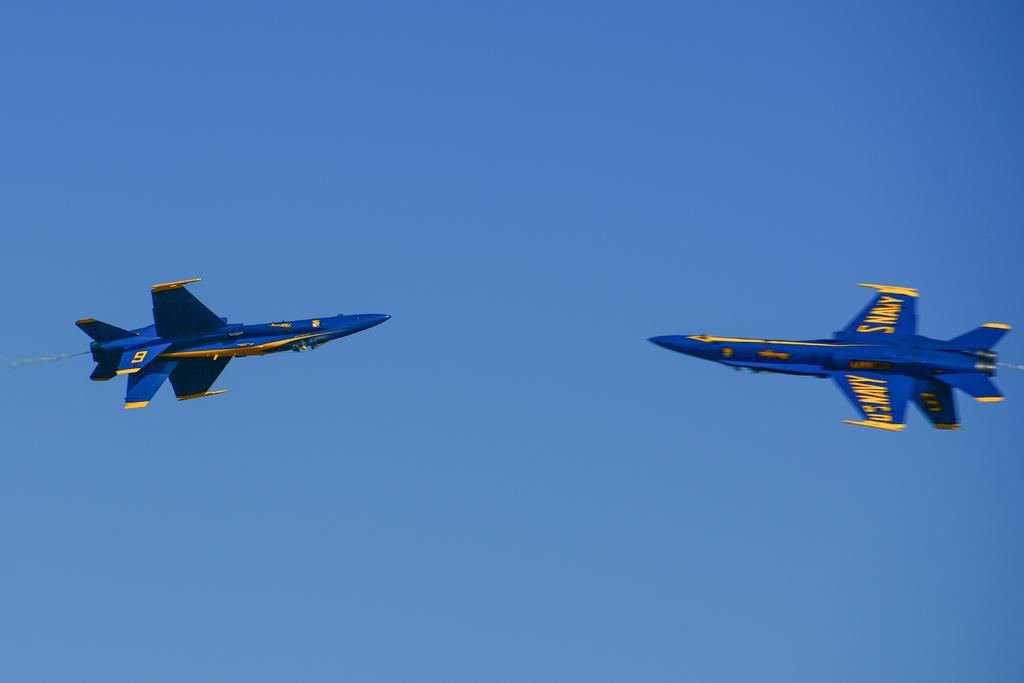Describe this image in one or two sentences. In this image there are two air fighters facing each other. They are flying in the sky. 